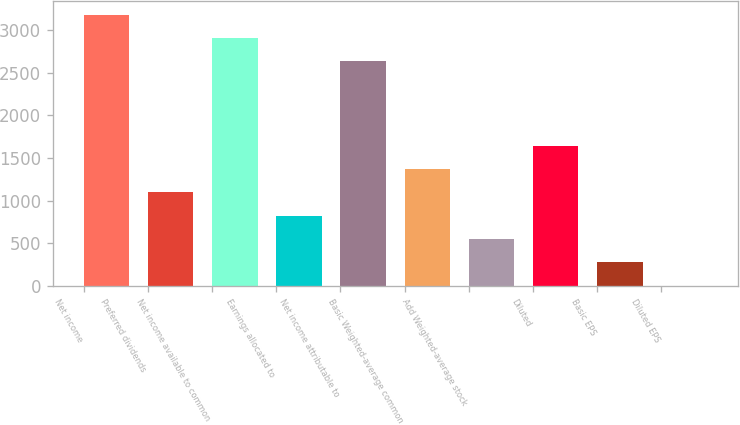Convert chart. <chart><loc_0><loc_0><loc_500><loc_500><bar_chart><fcel>Net income<fcel>Preferred dividends<fcel>Net income available to common<fcel>Earnings allocated to<fcel>Net income attributable to<fcel>Basic Weighted-average common<fcel>Add Weighted-average stock<fcel>Diluted<fcel>Basic EPS<fcel>Diluted EPS<nl><fcel>3180.6<fcel>1096.17<fcel>2907.3<fcel>822.87<fcel>2634<fcel>1369.47<fcel>549.57<fcel>1642.77<fcel>276.27<fcel>2.97<nl></chart> 